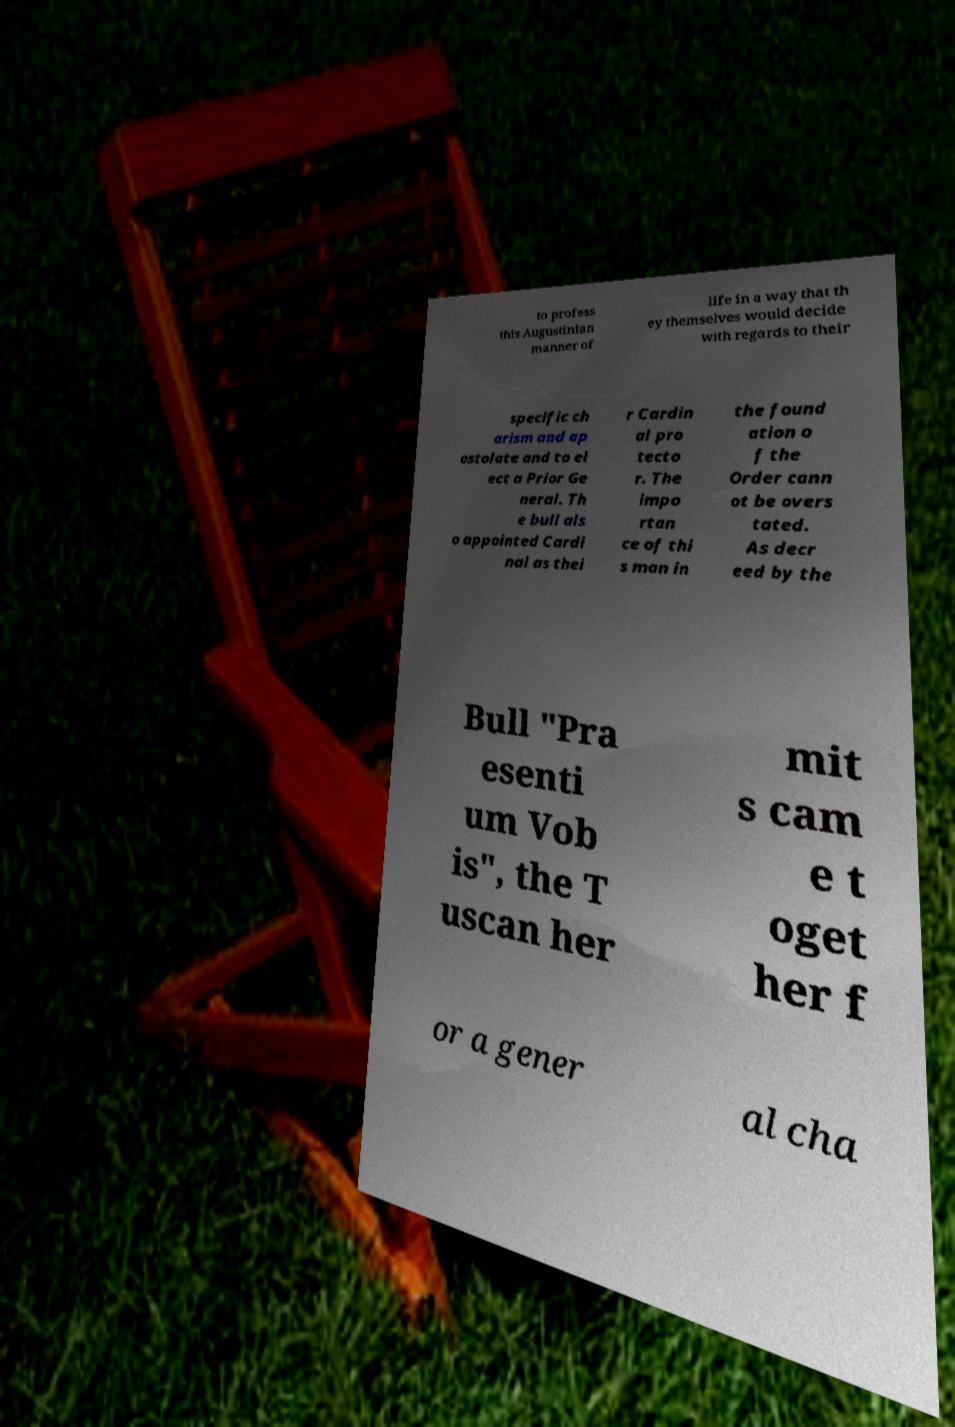Could you extract and type out the text from this image? to profess this Augustinian manner of life in a way that th ey themselves would decide with regards to their specific ch arism and ap ostolate and to el ect a Prior Ge neral. Th e bull als o appointed Cardi nal as thei r Cardin al pro tecto r. The impo rtan ce of thi s man in the found ation o f the Order cann ot be overs tated. As decr eed by the Bull "Pra esenti um Vob is", the T uscan her mit s cam e t oget her f or a gener al cha 